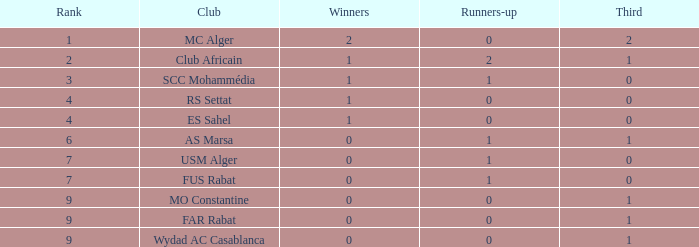Which Winners is the highest one that has a Rank larger than 7, and a Third smaller than 1? None. 